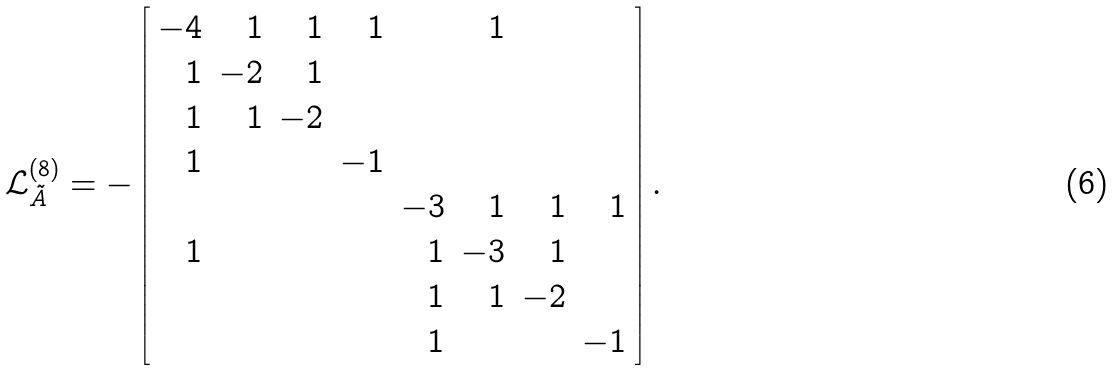Convert formula to latex. <formula><loc_0><loc_0><loc_500><loc_500>\mathcal { L } ^ { ( 8 ) } _ { \tilde { A } } = - \left [ \begin{array} { r r r r r r r r } - 4 & 1 & 1 & 1 & & 1 & & \\ 1 & - 2 & 1 & & & & & \\ 1 & 1 & - 2 & & & & & \\ 1 & & & - 1 & & & & \\ & & & & - 3 & 1 & 1 & 1 \\ 1 & & & & 1 & - 3 & 1 & \\ & & & & 1 & 1 & - 2 & \\ & & & & 1 & & & - 1 \\ \end{array} \right ] .</formula> 